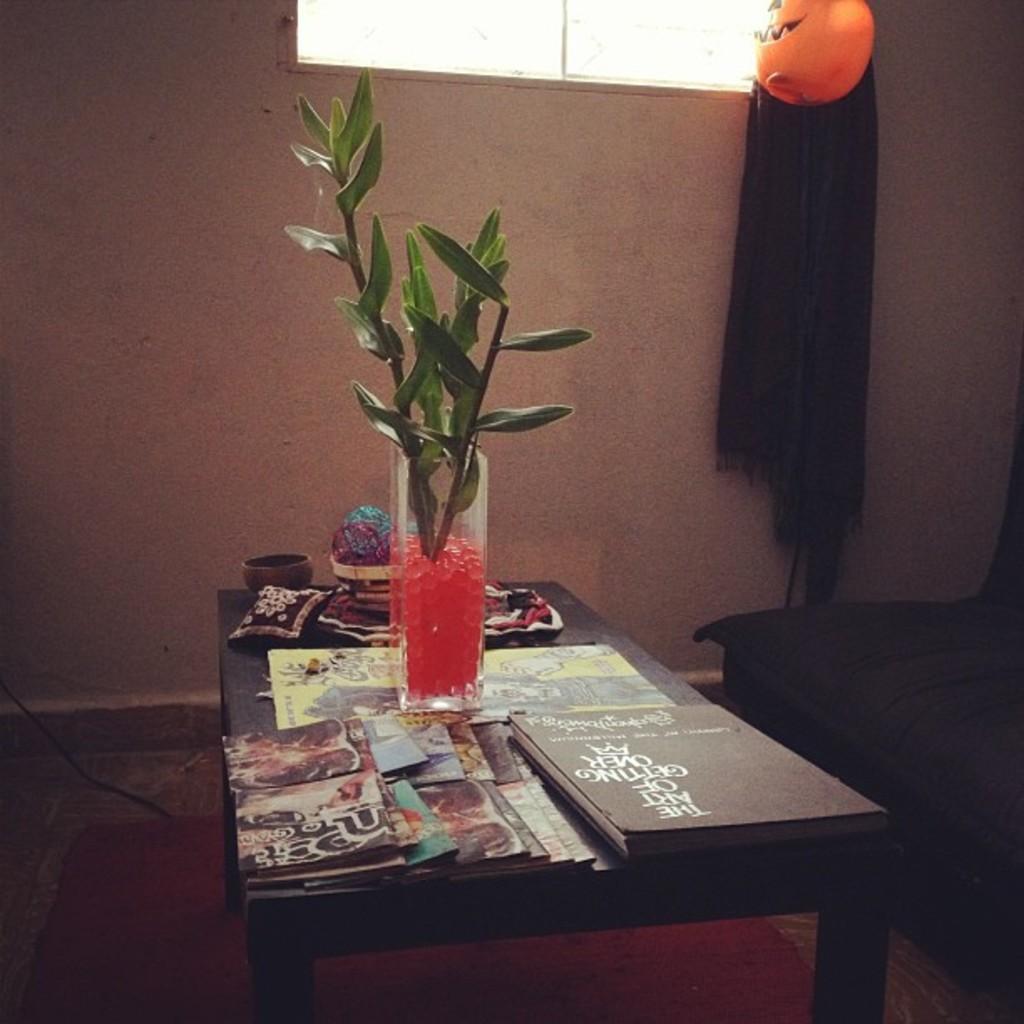How would you summarize this image in a sentence or two? In this picture we can see table and ion table we have vase plant in it, small pillow, book, cards, bowl, cloth and aside to this there is chair and in the background we can see wall, window, scarf, pumpkin. 